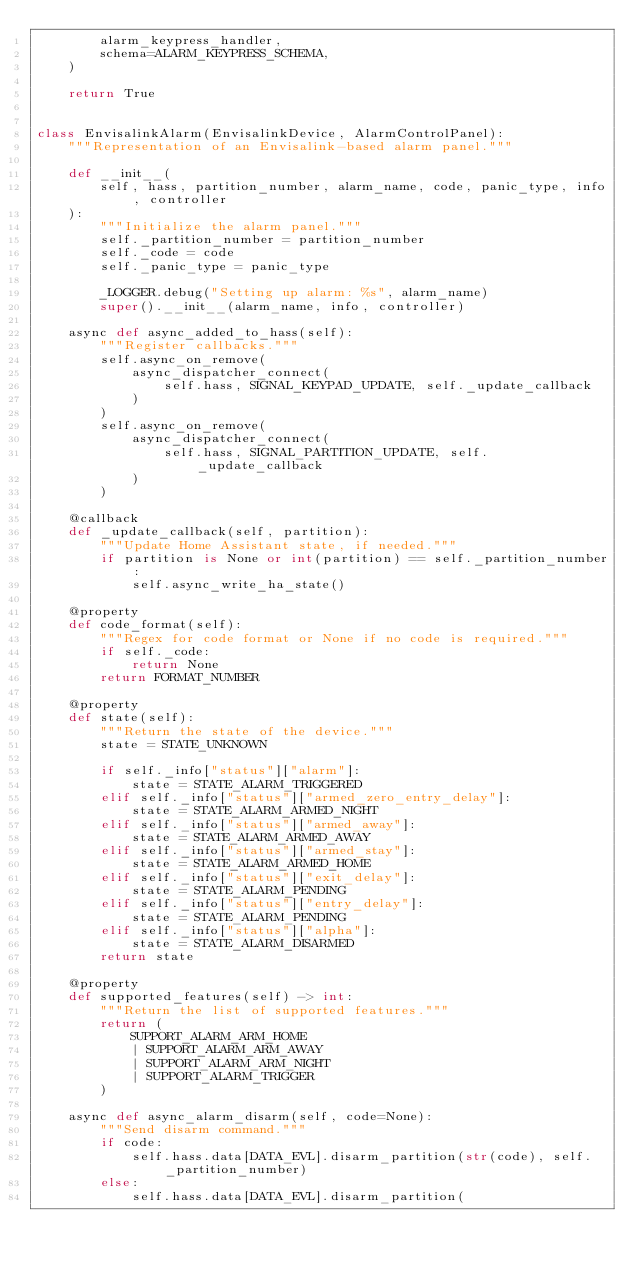<code> <loc_0><loc_0><loc_500><loc_500><_Python_>        alarm_keypress_handler,
        schema=ALARM_KEYPRESS_SCHEMA,
    )

    return True


class EnvisalinkAlarm(EnvisalinkDevice, AlarmControlPanel):
    """Representation of an Envisalink-based alarm panel."""

    def __init__(
        self, hass, partition_number, alarm_name, code, panic_type, info, controller
    ):
        """Initialize the alarm panel."""
        self._partition_number = partition_number
        self._code = code
        self._panic_type = panic_type

        _LOGGER.debug("Setting up alarm: %s", alarm_name)
        super().__init__(alarm_name, info, controller)

    async def async_added_to_hass(self):
        """Register callbacks."""
        self.async_on_remove(
            async_dispatcher_connect(
                self.hass, SIGNAL_KEYPAD_UPDATE, self._update_callback
            )
        )
        self.async_on_remove(
            async_dispatcher_connect(
                self.hass, SIGNAL_PARTITION_UPDATE, self._update_callback
            )
        )

    @callback
    def _update_callback(self, partition):
        """Update Home Assistant state, if needed."""
        if partition is None or int(partition) == self._partition_number:
            self.async_write_ha_state()

    @property
    def code_format(self):
        """Regex for code format or None if no code is required."""
        if self._code:
            return None
        return FORMAT_NUMBER

    @property
    def state(self):
        """Return the state of the device."""
        state = STATE_UNKNOWN

        if self._info["status"]["alarm"]:
            state = STATE_ALARM_TRIGGERED
        elif self._info["status"]["armed_zero_entry_delay"]:
            state = STATE_ALARM_ARMED_NIGHT
        elif self._info["status"]["armed_away"]:
            state = STATE_ALARM_ARMED_AWAY
        elif self._info["status"]["armed_stay"]:
            state = STATE_ALARM_ARMED_HOME
        elif self._info["status"]["exit_delay"]:
            state = STATE_ALARM_PENDING
        elif self._info["status"]["entry_delay"]:
            state = STATE_ALARM_PENDING
        elif self._info["status"]["alpha"]:
            state = STATE_ALARM_DISARMED
        return state

    @property
    def supported_features(self) -> int:
        """Return the list of supported features."""
        return (
            SUPPORT_ALARM_ARM_HOME
            | SUPPORT_ALARM_ARM_AWAY
            | SUPPORT_ALARM_ARM_NIGHT
            | SUPPORT_ALARM_TRIGGER
        )

    async def async_alarm_disarm(self, code=None):
        """Send disarm command."""
        if code:
            self.hass.data[DATA_EVL].disarm_partition(str(code), self._partition_number)
        else:
            self.hass.data[DATA_EVL].disarm_partition(</code> 